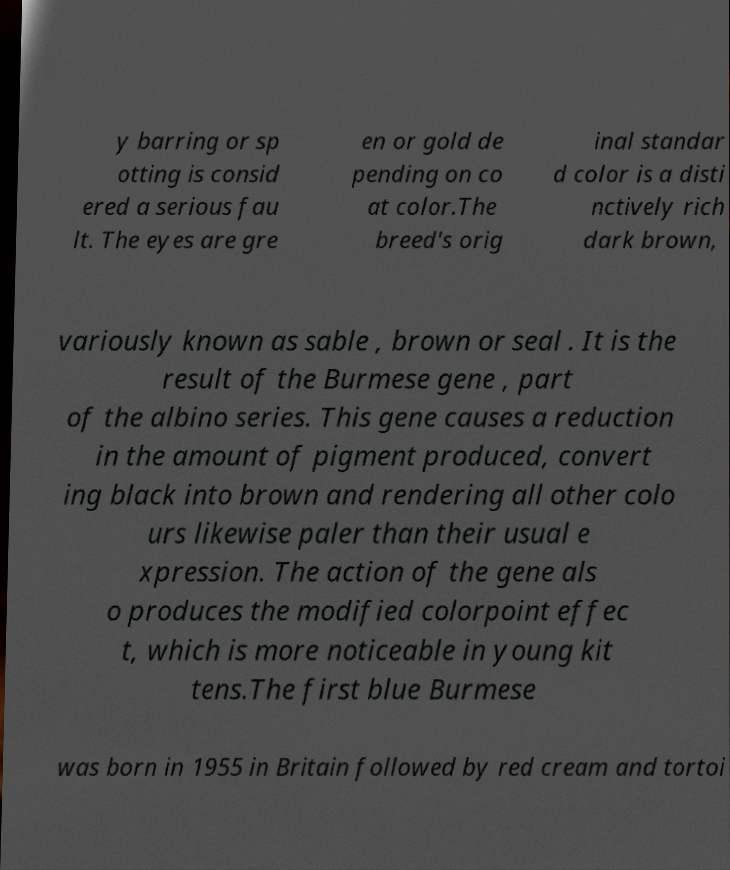I need the written content from this picture converted into text. Can you do that? y barring or sp otting is consid ered a serious fau lt. The eyes are gre en or gold de pending on co at color.The breed's orig inal standar d color is a disti nctively rich dark brown, variously known as sable , brown or seal . It is the result of the Burmese gene , part of the albino series. This gene causes a reduction in the amount of pigment produced, convert ing black into brown and rendering all other colo urs likewise paler than their usual e xpression. The action of the gene als o produces the modified colorpoint effec t, which is more noticeable in young kit tens.The first blue Burmese was born in 1955 in Britain followed by red cream and tortoi 